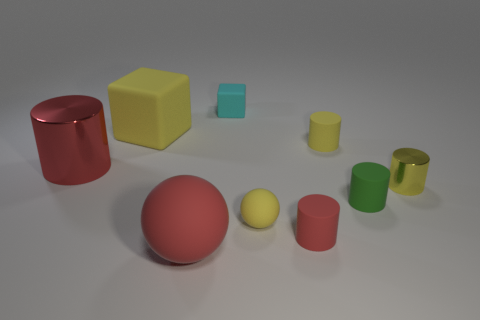Subtract all spheres. How many objects are left? 7 Subtract 0 brown spheres. How many objects are left? 9 Subtract all small green objects. Subtract all tiny green rubber objects. How many objects are left? 7 Add 9 yellow matte spheres. How many yellow matte spheres are left? 10 Add 3 green cylinders. How many green cylinders exist? 4 